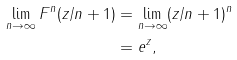Convert formula to latex. <formula><loc_0><loc_0><loc_500><loc_500>\lim _ { n \to \infty } F ^ { n } ( z / n + 1 ) & = \lim _ { n \to \infty } ( z / n + 1 ) ^ { n } \\ & = e ^ { z } ,</formula> 